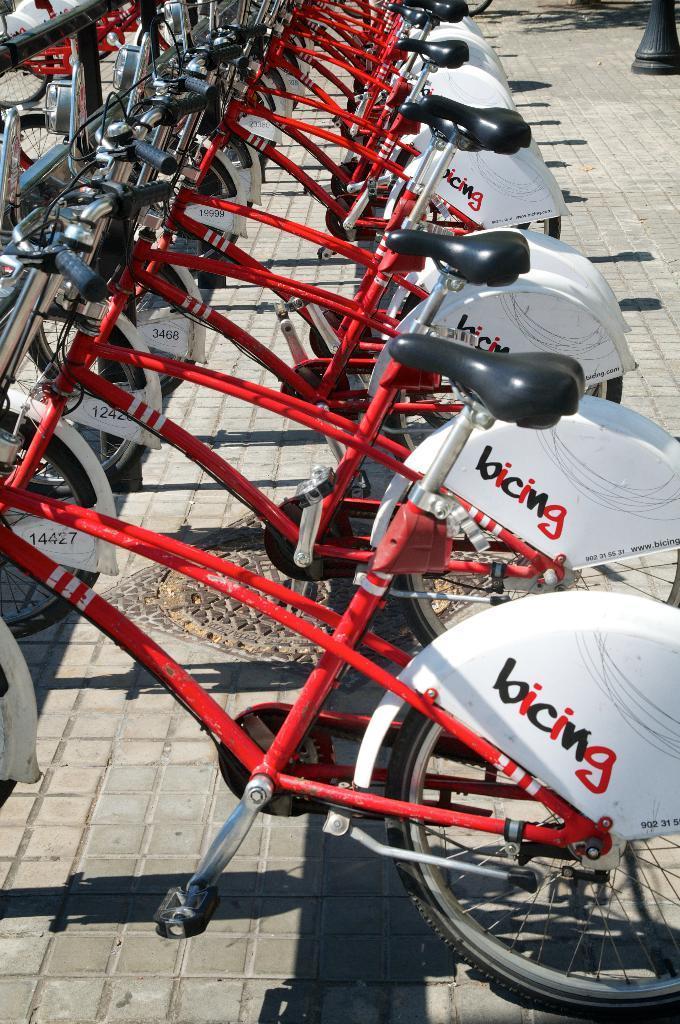Describe this image in one or two sentences. In this picture, we can see a few bicycles, and the ground, we can see spoke black color object in the top right corner of the picture. 